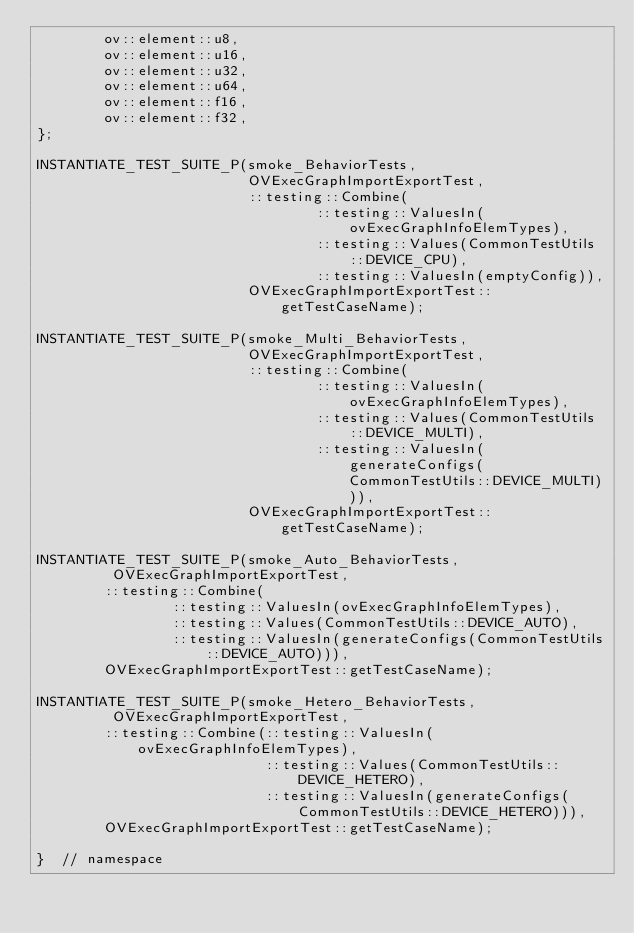Convert code to text. <code><loc_0><loc_0><loc_500><loc_500><_C++_>        ov::element::u8,
        ov::element::u16,
        ov::element::u32,
        ov::element::u64,
        ov::element::f16,
        ov::element::f32,
};

INSTANTIATE_TEST_SUITE_P(smoke_BehaviorTests,
                         OVExecGraphImportExportTest,
                         ::testing::Combine(
                                 ::testing::ValuesIn(ovExecGraphInfoElemTypes),
                                 ::testing::Values(CommonTestUtils::DEVICE_CPU),
                                 ::testing::ValuesIn(emptyConfig)),
                         OVExecGraphImportExportTest::getTestCaseName);

INSTANTIATE_TEST_SUITE_P(smoke_Multi_BehaviorTests,
                         OVExecGraphImportExportTest,
                         ::testing::Combine(
                                 ::testing::ValuesIn(ovExecGraphInfoElemTypes),
                                 ::testing::Values(CommonTestUtils::DEVICE_MULTI),
                                 ::testing::ValuesIn(generateConfigs(CommonTestUtils::DEVICE_MULTI))),
                         OVExecGraphImportExportTest::getTestCaseName);

INSTANTIATE_TEST_SUITE_P(smoke_Auto_BehaviorTests,
         OVExecGraphImportExportTest,
        ::testing::Combine(
                ::testing::ValuesIn(ovExecGraphInfoElemTypes),
                ::testing::Values(CommonTestUtils::DEVICE_AUTO),
                ::testing::ValuesIn(generateConfigs(CommonTestUtils::DEVICE_AUTO))),
        OVExecGraphImportExportTest::getTestCaseName);

INSTANTIATE_TEST_SUITE_P(smoke_Hetero_BehaviorTests,
         OVExecGraphImportExportTest,
        ::testing::Combine(::testing::ValuesIn(ovExecGraphInfoElemTypes),
                           ::testing::Values(CommonTestUtils::DEVICE_HETERO),
                           ::testing::ValuesIn(generateConfigs(CommonTestUtils::DEVICE_HETERO))),
        OVExecGraphImportExportTest::getTestCaseName);

}  // namespace</code> 